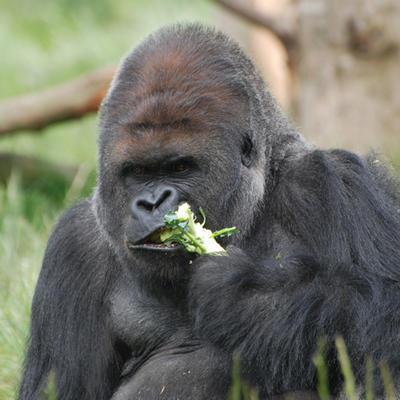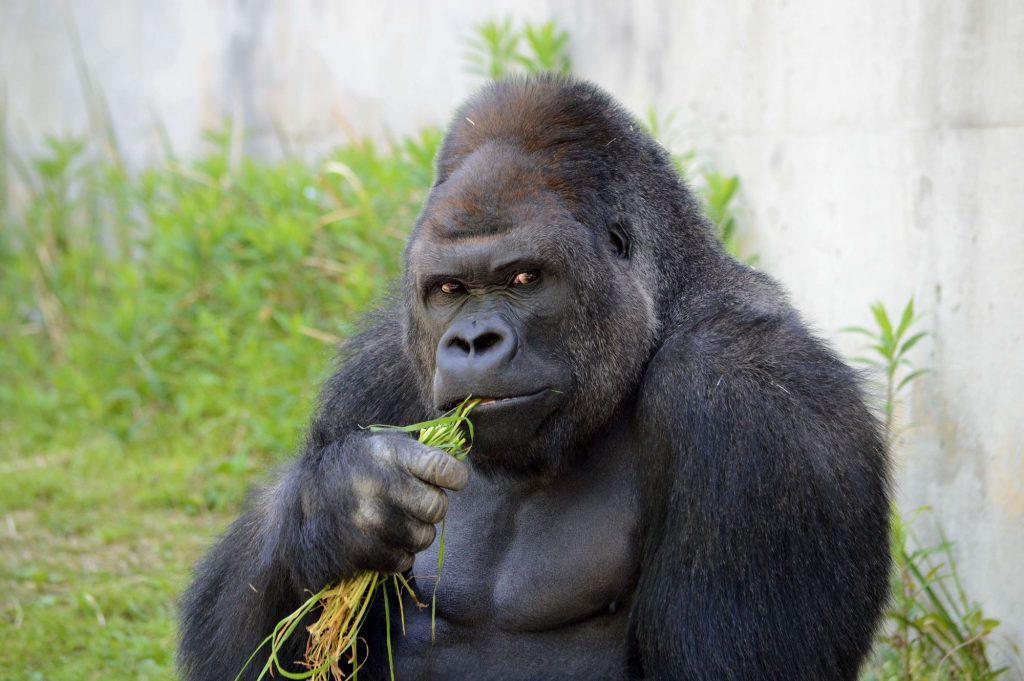The first image is the image on the left, the second image is the image on the right. Examine the images to the left and right. Is the description "All of the gorillas are holding food in their left hand." accurate? Answer yes or no. No. The first image is the image on the left, the second image is the image on the right. Analyze the images presented: Is the assertion "In the right image, a gorilla is holding green foliage to its mouth with the arm on the left [of the image]." valid? Answer yes or no. Yes. 